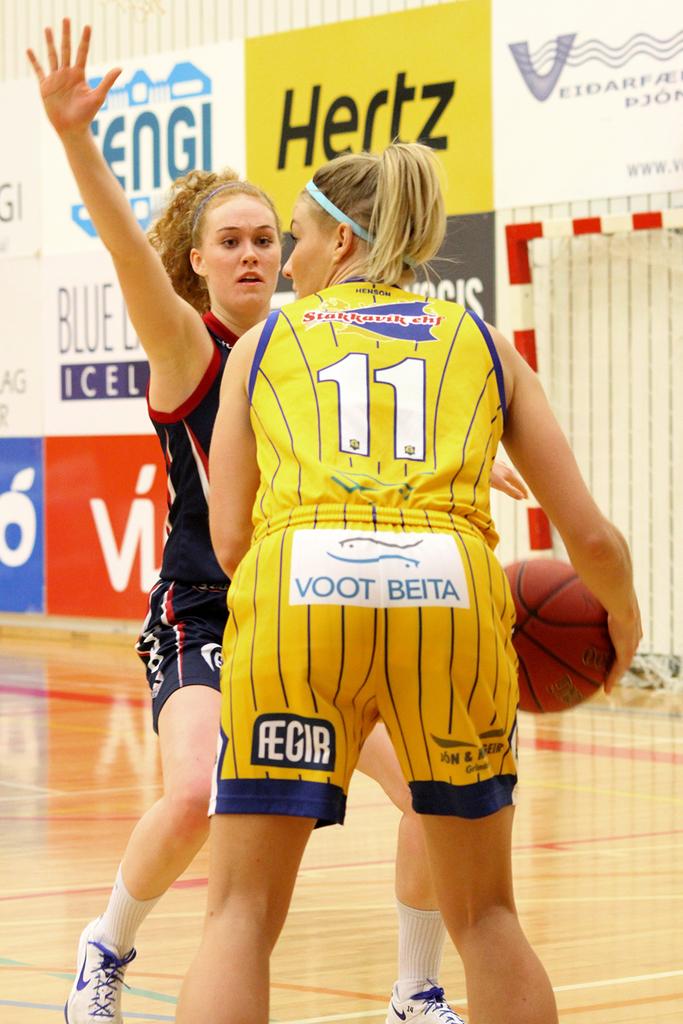What number is the player?
Ensure brevity in your answer.  11. What number is the yellow player?
Make the answer very short. 11. 